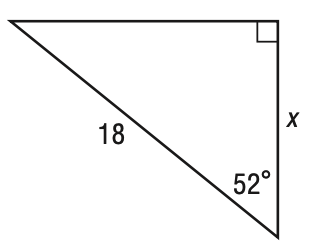Question: What is the value of x in the figure below? Round to the nearest tenth.
Choices:
A. 10.5
B. 11.1
C. 13.6
D. 14.2
Answer with the letter. Answer: B 